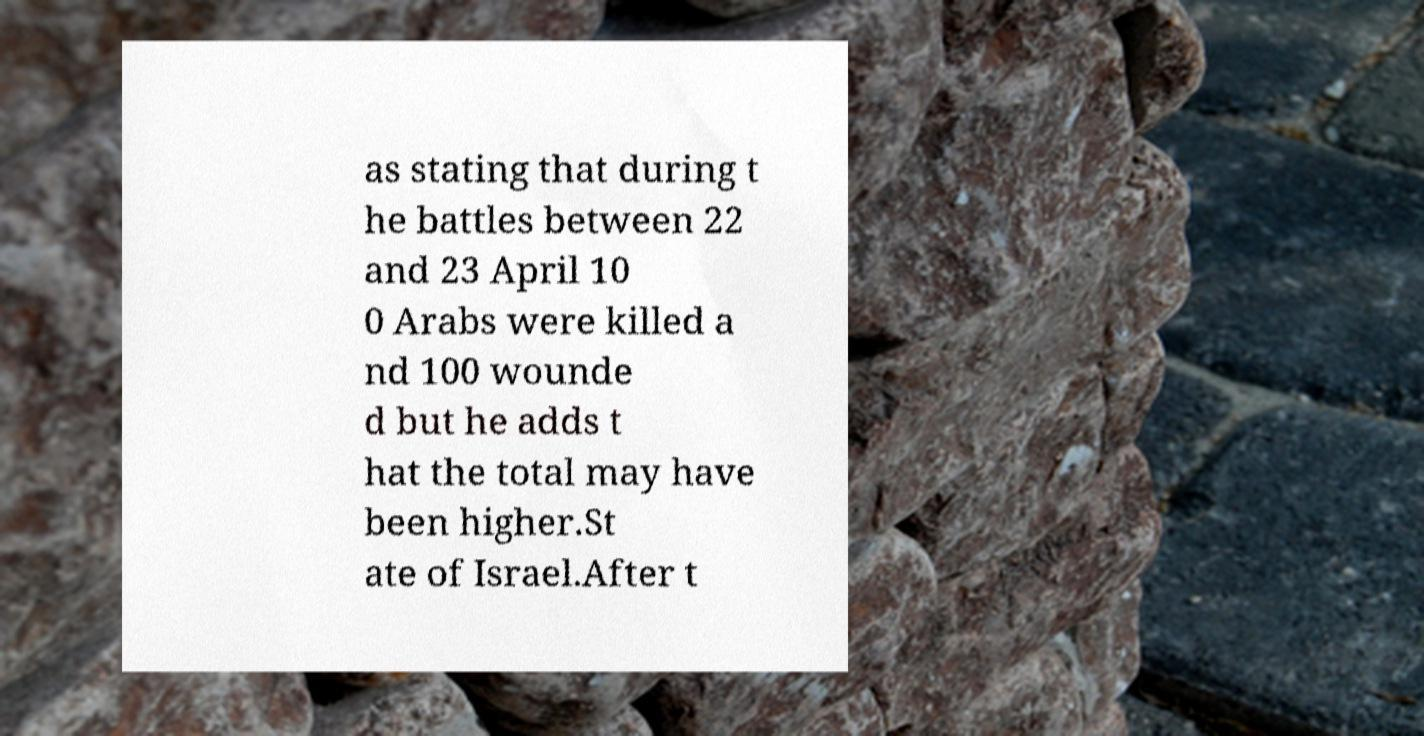Can you accurately transcribe the text from the provided image for me? as stating that during t he battles between 22 and 23 April 10 0 Arabs were killed a nd 100 wounde d but he adds t hat the total may have been higher.St ate of Israel.After t 